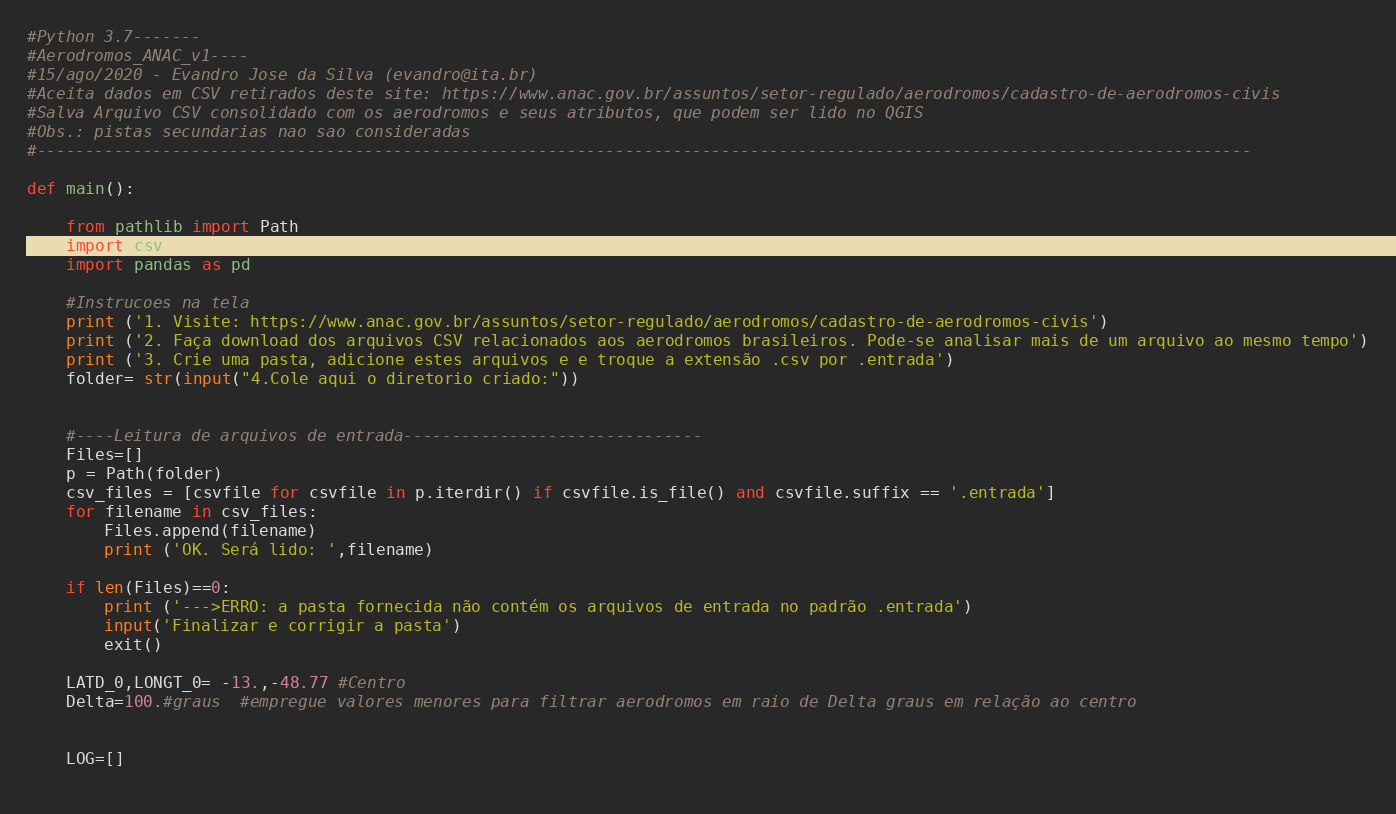Convert code to text. <code><loc_0><loc_0><loc_500><loc_500><_Python_>#Python 3.7-------
#Aerodromos_ANAC_v1----
#15/ago/2020 - Evandro Jose da Silva (evandro@ita.br)
#Aceita dados em CSV retirados deste site: https://www.anac.gov.br/assuntos/setor-regulado/aerodromos/cadastro-de-aerodromos-civis
#Salva Arquivo CSV consolidado com os aerodromos e seus atributos, que podem ser lido no QGIS
#Obs.: pistas secundarias nao sao consideradas
#------------------------------------------------------------------------------------------------------------------------------

def main():
        
	from pathlib import Path
	import csv
	import pandas as pd

	#Instrucoes na tela
	print ('1. Visite: https://www.anac.gov.br/assuntos/setor-regulado/aerodromos/cadastro-de-aerodromos-civis')
	print ('2. Faça download dos arquivos CSV relacionados aos aerodromos brasileiros. Pode-se analisar mais de um arquivo ao mesmo tempo')
	print ('3. Crie uma pasta, adicione estes arquivos e e troque a extensão .csv por .entrada')
	folder= str(input("4.Cole aqui o diretorio criado:"))
	
	
	#----Leitura de arquivos de entrada-------------------------------
	Files=[]
	p = Path(folder)
	csv_files = [csvfile for csvfile in p.iterdir() if csvfile.is_file() and csvfile.suffix == '.entrada']
	for filename in csv_files:
	    Files.append(filename)
	    print ('OK. Será lido: ',filename)
	
	if len(Files)==0:
	    print ('--->ERRO: a pasta fornecida não contém os arquivos de entrada no padrão .entrada')
	    input('Finalizar e corrigir a pasta')
	    exit()
	
	LATD_0,LONGT_0= -13.,-48.77 #Centro
	Delta=100.#graus  #empregue valores menores para filtrar aerodromos em raio de Delta graus em relação ao centro
	
	
	LOG=[]
	</code> 